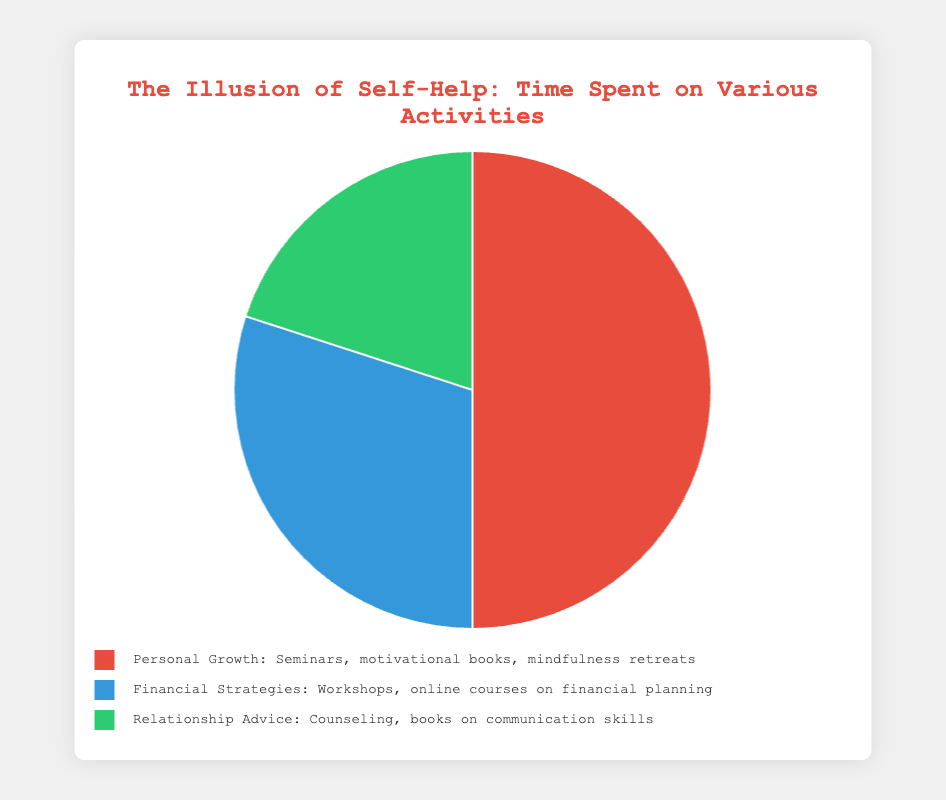What percentage of time is spent on activities focused on financial independence compared to personal relationships? According to the chart, time spent on financial strategies is 30%, and time spent on relationship advice is 20%. We compare these two percentages directly.
Answer: 30% compared to 20% What's the total percentage of time spent on financial strategies and relationship advice combined? The pie chart shows 30% for financial strategies and 20% for relationship advice. Adding these together gives 30% + 20% = 50%.
Answer: 50% Which activity category takes up the most time? By inspecting the chart, the largest section is attributed to personal growth, which has the highest percentage of 50%.
Answer: Personal Growth What is the difference in percentage between time spent on personal growth and financial strategies? The chart indicates 50% for personal growth and 30% for financial strategies. The difference is calculated as 50% - 30% = 20%.
Answer: 20% Are more than half of the activities dedicated to personal growth alone? The chart shows that personal growth occupies 50% of the time, which is exactly half. Thus, it doesn’t exceed half.
Answer: No If the time spent on personal growth and financial strategies were swapped, what would be the new percentage for personal growth? Currently, personal growth is 50% and financial strategies are 30%. If swapped, personal growth would then become 30%.
Answer: 30% How many times greater is the time spent on personal growth compared to relationship advice? According to the chart, personal growth is 50% and relationship advice is 20%. By dividing these, we find 50% / 20% = 2.5 times greater.
Answer: 2.5 times What is the average percentage of time spent per activity category? Summing the percentages: 50% + 30% + 20% = 100%. To find the average, divide by 3: 100% / 3 ≈ 33.33%.
Answer: 33.33% What color represents the section with the least amount of time spent? The least time spent is on relationship advice at 20%, which is visually represented by the green segment in the pie chart.
Answer: Green What fraction of the time is spent on personal growth, expressed as a fraction of the whole pie chart? Personal growth takes up 50% of the whole. As a fraction, this is 50/100 or simplified to 1/2.
Answer: 1/2 